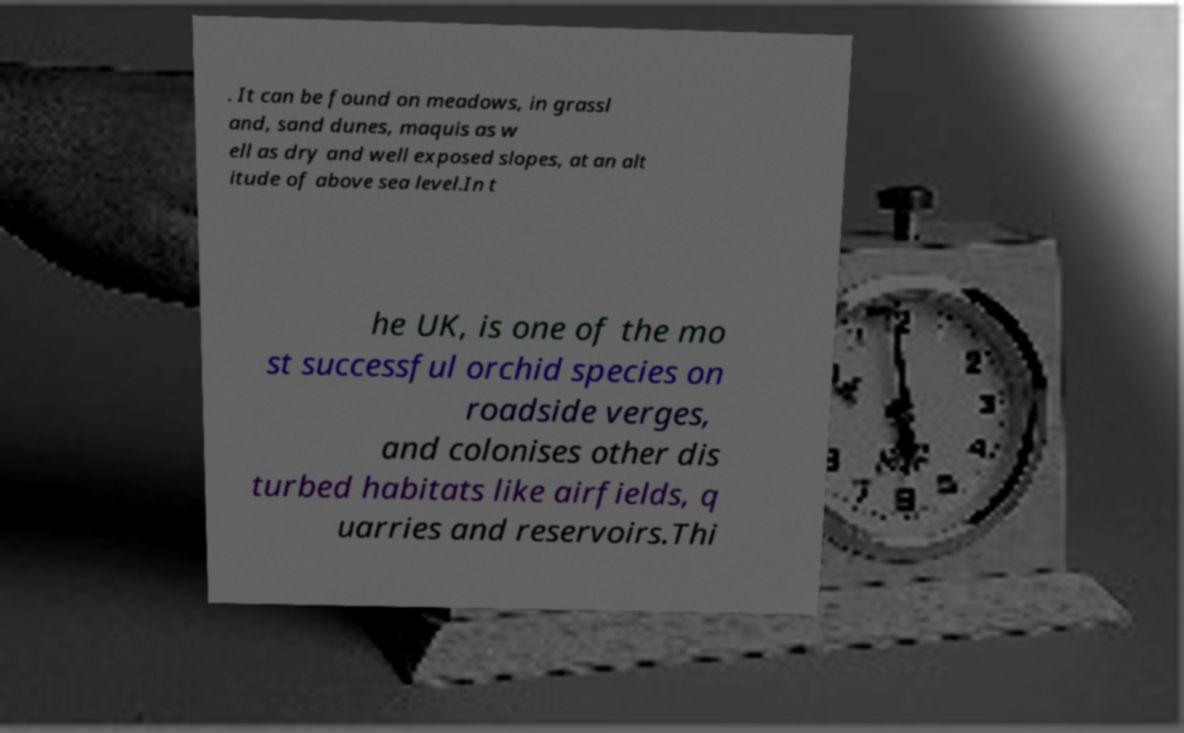Can you read and provide the text displayed in the image?This photo seems to have some interesting text. Can you extract and type it out for me? . It can be found on meadows, in grassl and, sand dunes, maquis as w ell as dry and well exposed slopes, at an alt itude of above sea level.In t he UK, is one of the mo st successful orchid species on roadside verges, and colonises other dis turbed habitats like airfields, q uarries and reservoirs.Thi 